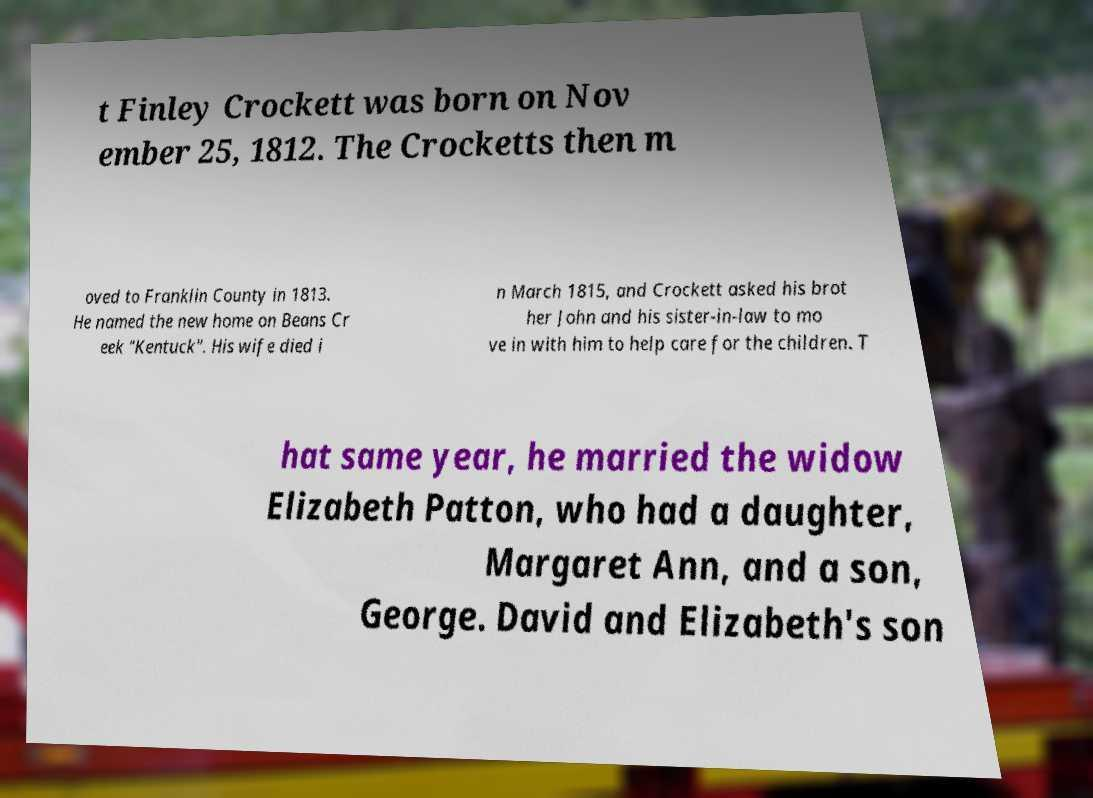I need the written content from this picture converted into text. Can you do that? t Finley Crockett was born on Nov ember 25, 1812. The Crocketts then m oved to Franklin County in 1813. He named the new home on Beans Cr eek "Kentuck". His wife died i n March 1815, and Crockett asked his brot her John and his sister-in-law to mo ve in with him to help care for the children. T hat same year, he married the widow Elizabeth Patton, who had a daughter, Margaret Ann, and a son, George. David and Elizabeth's son 